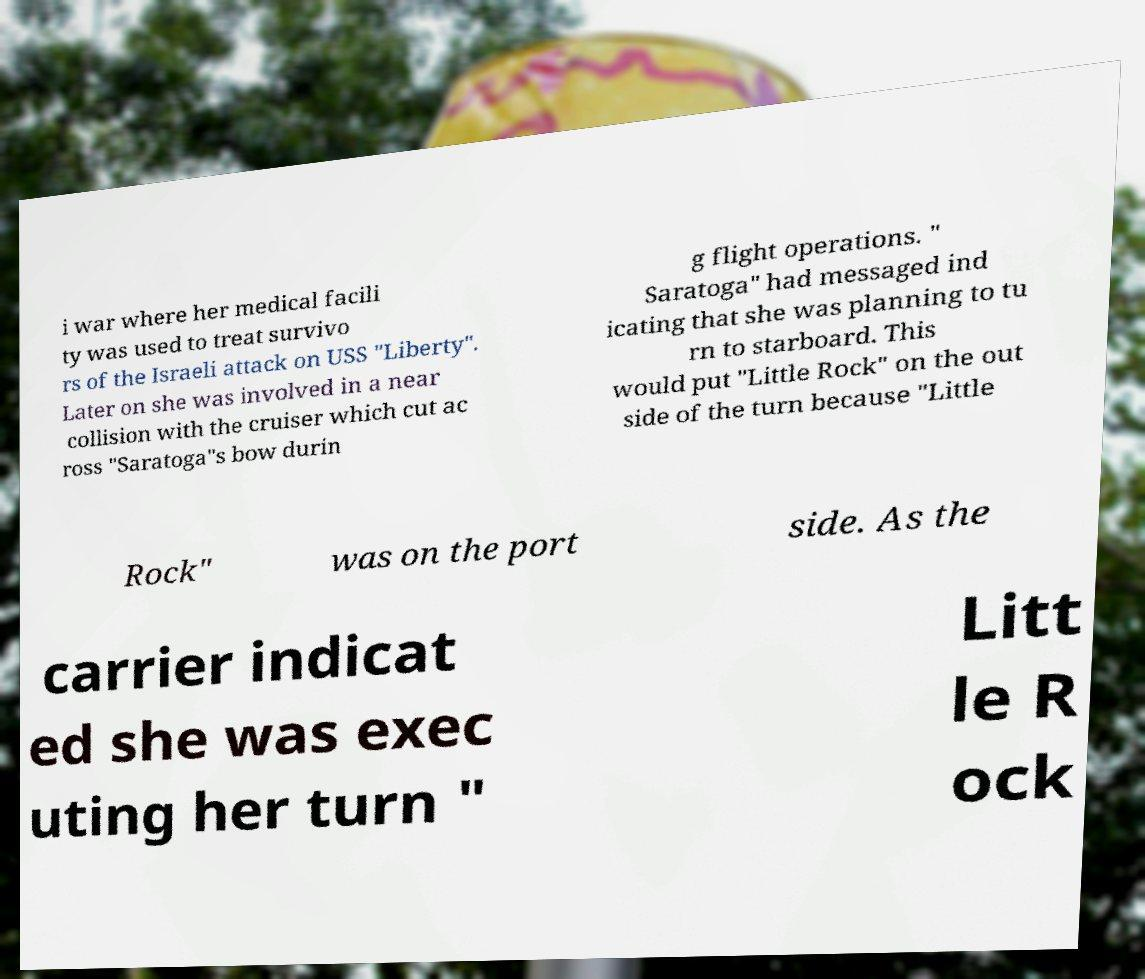Could you extract and type out the text from this image? i war where her medical facili ty was used to treat survivo rs of the Israeli attack on USS "Liberty". Later on she was involved in a near collision with the cruiser which cut ac ross "Saratoga"s bow durin g flight operations. " Saratoga" had messaged ind icating that she was planning to tu rn to starboard. This would put "Little Rock" on the out side of the turn because "Little Rock" was on the port side. As the carrier indicat ed she was exec uting her turn " Litt le R ock 